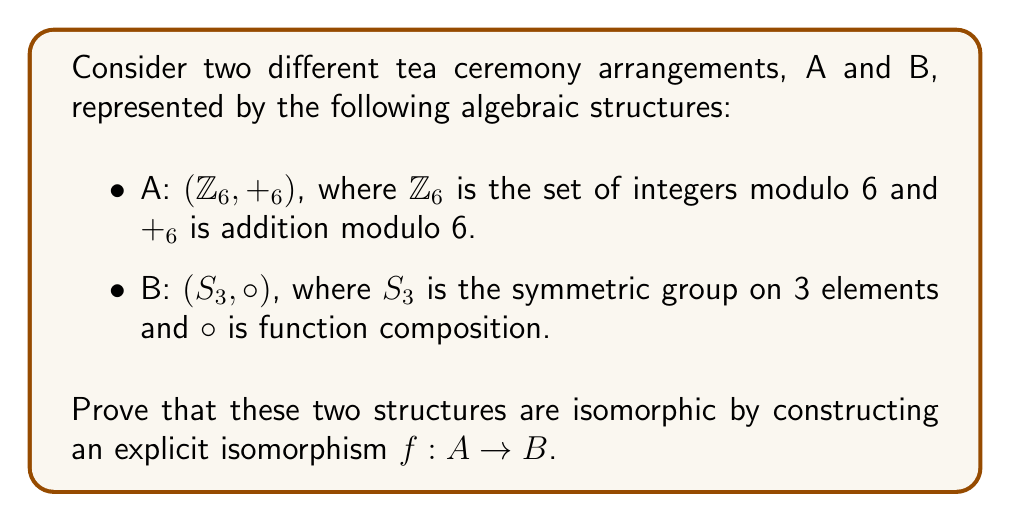Could you help me with this problem? To prove that the two structures are isomorphic, we need to construct a bijective function $f: A \to B$ that preserves the group operation. We'll follow these steps:

1. Define the function $f: A \to B$:
   Let $f: Z_6 \to S_3$ be defined as follows:
   $f(0) = (1)$ (identity permutation)
   $f(1) = (123)$
   $f(2) = (132)$
   $f(3) = (23)$
   $f(4) = (13)$
   $f(5) = (12)$

2. Prove that $f$ is bijective:
   - $f$ is injective: Each element in $Z_6$ maps to a unique element in $S_3$.
   - $f$ is surjective: The image of $f$ covers all elements in $S_3$.
   Therefore, $f$ is bijective.

3. Prove that $f$ preserves the group operation:
   We need to show that $f(a +_6 b) = f(a) \circ f(b)$ for all $a, b \in Z_6$.

   Let's verify this for a few cases:
   a) $f(1 +_6 2) = f(3) = (23)$
      $f(1) \circ f(2) = (123) \circ (132) = (23)$

   b) $f(2 +_6 5) = f(1) = (123)$
      $f(2) \circ f(5) = (132) \circ (12) = (123)$

   c) $f(4 +_6 3) = f(1) = (123)$
      $f(4) \circ f(3) = (13) \circ (23) = (123)$

   We can continue this process to verify that the property holds for all pairs of elements in $Z_6$.

4. Conclusion:
   Since $f$ is bijective and preserves the group operation, it is an isomorphism between $(Z_6, +_6)$ and $(S_3, \circ)$.
Answer: The isomorphism $f: (Z_6, +_6) \to (S_3, \circ)$ is given by:
$f(0) = (1)$
$f(1) = (123)$
$f(2) = (132)$
$f(3) = (23)$
$f(4) = (13)$
$f(5) = (12)$

This function is bijective and preserves the group operation, thus proving that $(Z_6, +_6)$ and $(S_3, \circ)$ are isomorphic. 